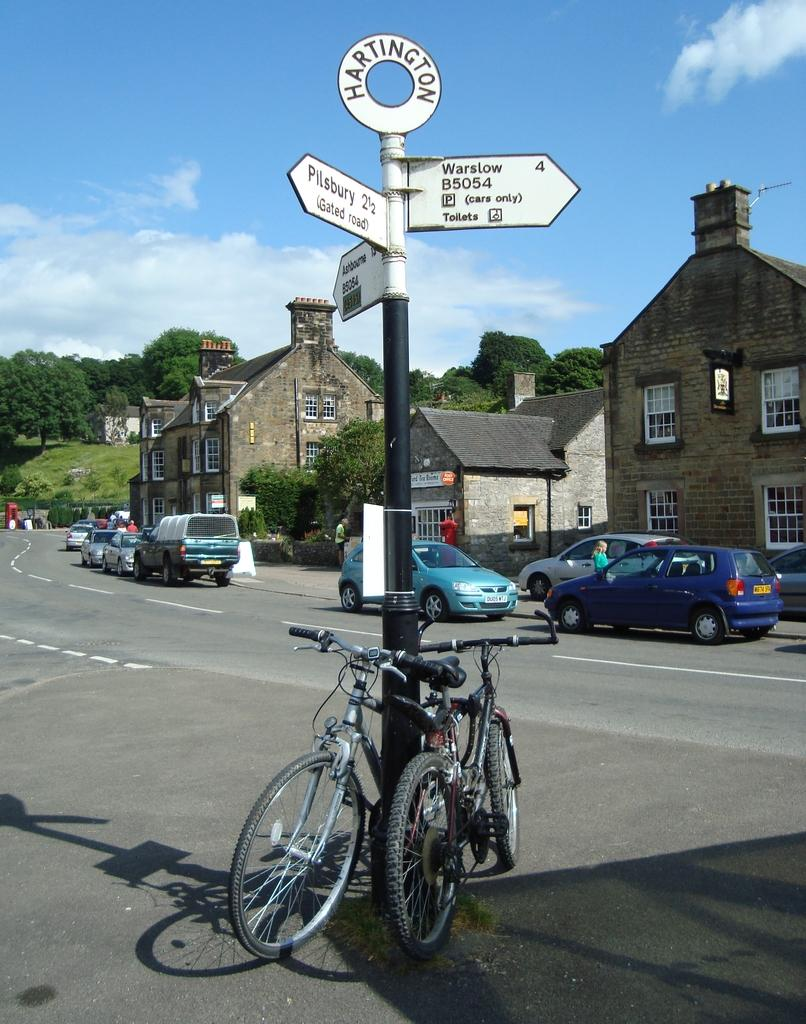What is happening on the road in the image? Vehicles are moving on the road in the image. What structures can be seen in the image? There are buildings visible in the image. What type of vegetation is present in the image? Trees are present in the image. Where are the bicycles located in the image? Bicycles are placed near a pole in the image. What type of music is the band playing in the image? There is no band present in the image, so it is not possible to determine what type of music they might be playing. 